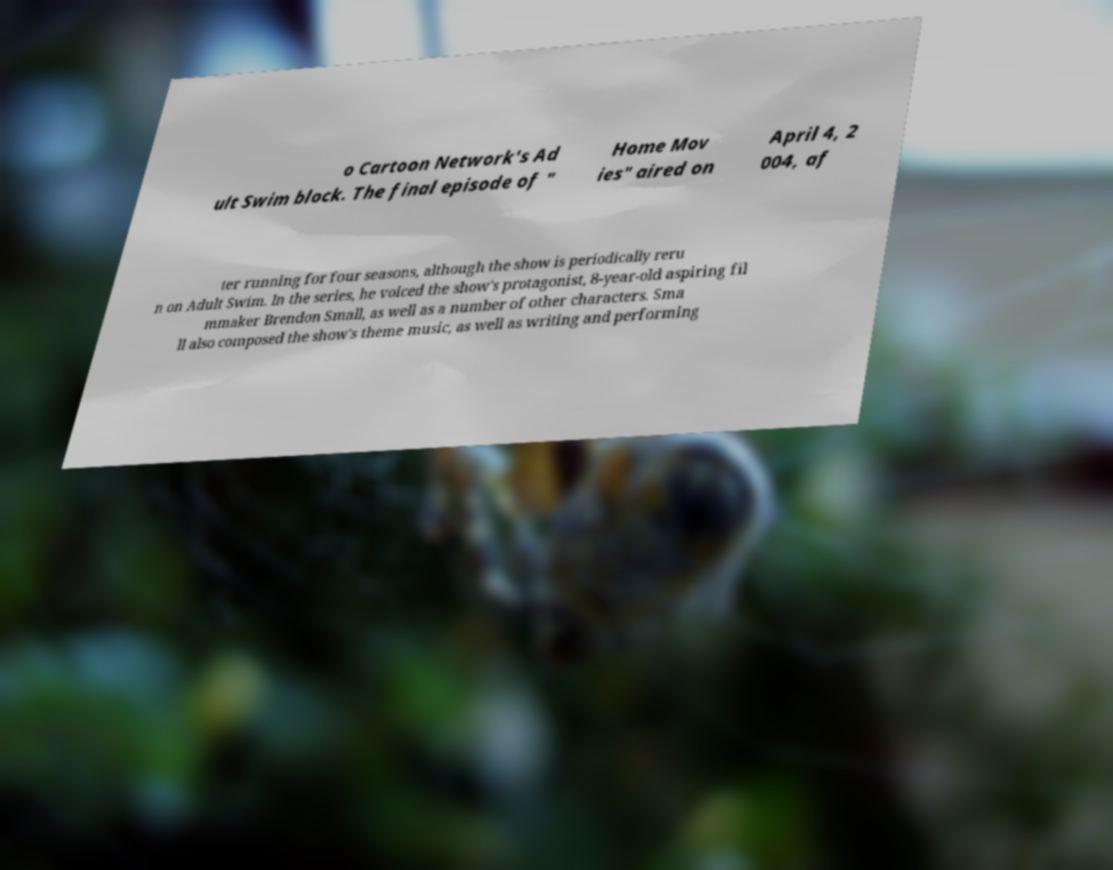There's text embedded in this image that I need extracted. Can you transcribe it verbatim? o Cartoon Network's Ad ult Swim block. The final episode of " Home Mov ies" aired on April 4, 2 004, af ter running for four seasons, although the show is periodically reru n on Adult Swim. In the series, he voiced the show's protagonist, 8-year-old aspiring fil mmaker Brendon Small, as well as a number of other characters. Sma ll also composed the show's theme music, as well as writing and performing 